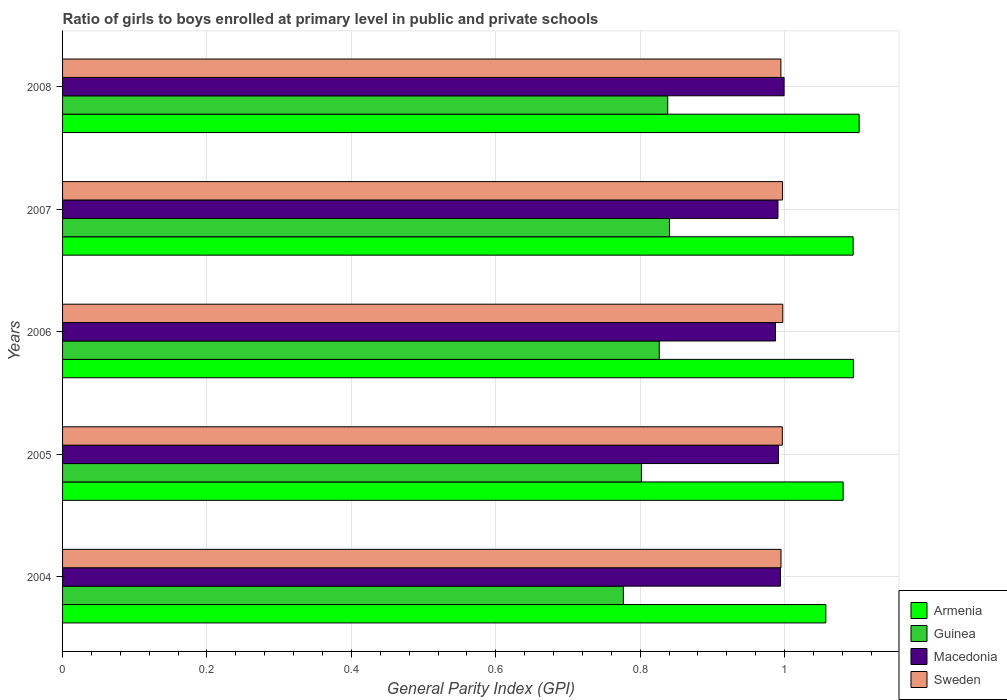How many groups of bars are there?
Your answer should be very brief. 5. Are the number of bars per tick equal to the number of legend labels?
Provide a short and direct response. Yes. How many bars are there on the 5th tick from the top?
Provide a succinct answer. 4. How many bars are there on the 1st tick from the bottom?
Offer a terse response. 4. What is the label of the 5th group of bars from the top?
Your response must be concise. 2004. In how many cases, is the number of bars for a given year not equal to the number of legend labels?
Ensure brevity in your answer.  0. What is the general parity index in Sweden in 2004?
Make the answer very short. 1. Across all years, what is the maximum general parity index in Macedonia?
Provide a short and direct response. 1. Across all years, what is the minimum general parity index in Sweden?
Give a very brief answer. 0.99. In which year was the general parity index in Sweden maximum?
Your response must be concise. 2006. What is the total general parity index in Sweden in the graph?
Give a very brief answer. 4.98. What is the difference between the general parity index in Sweden in 2004 and that in 2007?
Provide a succinct answer. -0. What is the difference between the general parity index in Guinea in 2006 and the general parity index in Macedonia in 2007?
Keep it short and to the point. -0.16. What is the average general parity index in Macedonia per year?
Your answer should be very brief. 0.99. In the year 2007, what is the difference between the general parity index in Sweden and general parity index in Armenia?
Your answer should be very brief. -0.1. In how many years, is the general parity index in Macedonia greater than 1.08 ?
Your answer should be very brief. 0. What is the ratio of the general parity index in Guinea in 2005 to that in 2008?
Your answer should be very brief. 0.96. What is the difference between the highest and the second highest general parity index in Sweden?
Ensure brevity in your answer.  0. What is the difference between the highest and the lowest general parity index in Macedonia?
Your answer should be very brief. 0.01. In how many years, is the general parity index in Armenia greater than the average general parity index in Armenia taken over all years?
Ensure brevity in your answer.  3. What does the 4th bar from the bottom in 2004 represents?
Make the answer very short. Sweden. What is the difference between two consecutive major ticks on the X-axis?
Keep it short and to the point. 0.2. Are the values on the major ticks of X-axis written in scientific E-notation?
Your response must be concise. No. Does the graph contain grids?
Keep it short and to the point. Yes. Where does the legend appear in the graph?
Ensure brevity in your answer.  Bottom right. How many legend labels are there?
Give a very brief answer. 4. What is the title of the graph?
Give a very brief answer. Ratio of girls to boys enrolled at primary level in public and private schools. What is the label or title of the X-axis?
Provide a succinct answer. General Parity Index (GPI). What is the label or title of the Y-axis?
Give a very brief answer. Years. What is the General Parity Index (GPI) in Armenia in 2004?
Ensure brevity in your answer.  1.06. What is the General Parity Index (GPI) of Guinea in 2004?
Ensure brevity in your answer.  0.78. What is the General Parity Index (GPI) of Macedonia in 2004?
Make the answer very short. 0.99. What is the General Parity Index (GPI) of Sweden in 2004?
Keep it short and to the point. 1. What is the General Parity Index (GPI) of Armenia in 2005?
Your response must be concise. 1.08. What is the General Parity Index (GPI) in Guinea in 2005?
Give a very brief answer. 0.8. What is the General Parity Index (GPI) of Macedonia in 2005?
Ensure brevity in your answer.  0.99. What is the General Parity Index (GPI) of Sweden in 2005?
Offer a terse response. 1. What is the General Parity Index (GPI) in Armenia in 2006?
Give a very brief answer. 1.1. What is the General Parity Index (GPI) of Guinea in 2006?
Provide a succinct answer. 0.83. What is the General Parity Index (GPI) in Macedonia in 2006?
Your answer should be compact. 0.99. What is the General Parity Index (GPI) in Sweden in 2006?
Your answer should be compact. 1. What is the General Parity Index (GPI) in Armenia in 2007?
Give a very brief answer. 1.1. What is the General Parity Index (GPI) of Guinea in 2007?
Offer a terse response. 0.84. What is the General Parity Index (GPI) in Macedonia in 2007?
Offer a terse response. 0.99. What is the General Parity Index (GPI) in Sweden in 2007?
Provide a short and direct response. 1. What is the General Parity Index (GPI) of Armenia in 2008?
Keep it short and to the point. 1.1. What is the General Parity Index (GPI) of Guinea in 2008?
Make the answer very short. 0.84. What is the General Parity Index (GPI) of Macedonia in 2008?
Ensure brevity in your answer.  1. What is the General Parity Index (GPI) in Sweden in 2008?
Give a very brief answer. 0.99. Across all years, what is the maximum General Parity Index (GPI) of Armenia?
Provide a short and direct response. 1.1. Across all years, what is the maximum General Parity Index (GPI) in Guinea?
Offer a very short reply. 0.84. Across all years, what is the maximum General Parity Index (GPI) of Macedonia?
Provide a succinct answer. 1. Across all years, what is the maximum General Parity Index (GPI) of Sweden?
Offer a terse response. 1. Across all years, what is the minimum General Parity Index (GPI) of Armenia?
Make the answer very short. 1.06. Across all years, what is the minimum General Parity Index (GPI) of Guinea?
Offer a very short reply. 0.78. Across all years, what is the minimum General Parity Index (GPI) in Macedonia?
Your answer should be very brief. 0.99. Across all years, what is the minimum General Parity Index (GPI) of Sweden?
Keep it short and to the point. 0.99. What is the total General Parity Index (GPI) of Armenia in the graph?
Provide a succinct answer. 5.43. What is the total General Parity Index (GPI) of Guinea in the graph?
Give a very brief answer. 4.08. What is the total General Parity Index (GPI) in Macedonia in the graph?
Provide a short and direct response. 4.96. What is the total General Parity Index (GPI) of Sweden in the graph?
Your answer should be compact. 4.98. What is the difference between the General Parity Index (GPI) of Armenia in 2004 and that in 2005?
Ensure brevity in your answer.  -0.02. What is the difference between the General Parity Index (GPI) in Guinea in 2004 and that in 2005?
Ensure brevity in your answer.  -0.03. What is the difference between the General Parity Index (GPI) of Macedonia in 2004 and that in 2005?
Keep it short and to the point. 0. What is the difference between the General Parity Index (GPI) in Sweden in 2004 and that in 2005?
Provide a succinct answer. -0. What is the difference between the General Parity Index (GPI) in Armenia in 2004 and that in 2006?
Provide a succinct answer. -0.04. What is the difference between the General Parity Index (GPI) of Guinea in 2004 and that in 2006?
Your answer should be compact. -0.05. What is the difference between the General Parity Index (GPI) of Macedonia in 2004 and that in 2006?
Make the answer very short. 0.01. What is the difference between the General Parity Index (GPI) of Sweden in 2004 and that in 2006?
Offer a very short reply. -0. What is the difference between the General Parity Index (GPI) of Armenia in 2004 and that in 2007?
Your answer should be compact. -0.04. What is the difference between the General Parity Index (GPI) in Guinea in 2004 and that in 2007?
Ensure brevity in your answer.  -0.06. What is the difference between the General Parity Index (GPI) of Macedonia in 2004 and that in 2007?
Offer a terse response. 0. What is the difference between the General Parity Index (GPI) of Sweden in 2004 and that in 2007?
Keep it short and to the point. -0. What is the difference between the General Parity Index (GPI) of Armenia in 2004 and that in 2008?
Offer a terse response. -0.05. What is the difference between the General Parity Index (GPI) of Guinea in 2004 and that in 2008?
Keep it short and to the point. -0.06. What is the difference between the General Parity Index (GPI) of Macedonia in 2004 and that in 2008?
Give a very brief answer. -0.01. What is the difference between the General Parity Index (GPI) of Sweden in 2004 and that in 2008?
Your answer should be very brief. 0. What is the difference between the General Parity Index (GPI) of Armenia in 2005 and that in 2006?
Make the answer very short. -0.01. What is the difference between the General Parity Index (GPI) in Guinea in 2005 and that in 2006?
Ensure brevity in your answer.  -0.02. What is the difference between the General Parity Index (GPI) of Macedonia in 2005 and that in 2006?
Ensure brevity in your answer.  0. What is the difference between the General Parity Index (GPI) in Sweden in 2005 and that in 2006?
Provide a succinct answer. -0. What is the difference between the General Parity Index (GPI) of Armenia in 2005 and that in 2007?
Provide a succinct answer. -0.01. What is the difference between the General Parity Index (GPI) in Guinea in 2005 and that in 2007?
Your answer should be very brief. -0.04. What is the difference between the General Parity Index (GPI) of Macedonia in 2005 and that in 2007?
Your answer should be very brief. 0. What is the difference between the General Parity Index (GPI) in Sweden in 2005 and that in 2007?
Your response must be concise. -0. What is the difference between the General Parity Index (GPI) in Armenia in 2005 and that in 2008?
Keep it short and to the point. -0.02. What is the difference between the General Parity Index (GPI) of Guinea in 2005 and that in 2008?
Offer a very short reply. -0.04. What is the difference between the General Parity Index (GPI) of Macedonia in 2005 and that in 2008?
Provide a succinct answer. -0.01. What is the difference between the General Parity Index (GPI) of Sweden in 2005 and that in 2008?
Your answer should be compact. 0. What is the difference between the General Parity Index (GPI) in Armenia in 2006 and that in 2007?
Make the answer very short. 0. What is the difference between the General Parity Index (GPI) in Guinea in 2006 and that in 2007?
Offer a terse response. -0.01. What is the difference between the General Parity Index (GPI) of Macedonia in 2006 and that in 2007?
Keep it short and to the point. -0. What is the difference between the General Parity Index (GPI) of Armenia in 2006 and that in 2008?
Make the answer very short. -0.01. What is the difference between the General Parity Index (GPI) in Guinea in 2006 and that in 2008?
Ensure brevity in your answer.  -0.01. What is the difference between the General Parity Index (GPI) in Macedonia in 2006 and that in 2008?
Your answer should be very brief. -0.01. What is the difference between the General Parity Index (GPI) in Sweden in 2006 and that in 2008?
Your answer should be very brief. 0. What is the difference between the General Parity Index (GPI) in Armenia in 2007 and that in 2008?
Make the answer very short. -0.01. What is the difference between the General Parity Index (GPI) in Guinea in 2007 and that in 2008?
Offer a terse response. 0. What is the difference between the General Parity Index (GPI) of Macedonia in 2007 and that in 2008?
Offer a terse response. -0.01. What is the difference between the General Parity Index (GPI) of Sweden in 2007 and that in 2008?
Offer a very short reply. 0. What is the difference between the General Parity Index (GPI) of Armenia in 2004 and the General Parity Index (GPI) of Guinea in 2005?
Offer a terse response. 0.26. What is the difference between the General Parity Index (GPI) of Armenia in 2004 and the General Parity Index (GPI) of Macedonia in 2005?
Provide a short and direct response. 0.07. What is the difference between the General Parity Index (GPI) of Armenia in 2004 and the General Parity Index (GPI) of Sweden in 2005?
Provide a short and direct response. 0.06. What is the difference between the General Parity Index (GPI) in Guinea in 2004 and the General Parity Index (GPI) in Macedonia in 2005?
Provide a short and direct response. -0.21. What is the difference between the General Parity Index (GPI) in Guinea in 2004 and the General Parity Index (GPI) in Sweden in 2005?
Provide a short and direct response. -0.22. What is the difference between the General Parity Index (GPI) of Macedonia in 2004 and the General Parity Index (GPI) of Sweden in 2005?
Your answer should be compact. -0. What is the difference between the General Parity Index (GPI) of Armenia in 2004 and the General Parity Index (GPI) of Guinea in 2006?
Ensure brevity in your answer.  0.23. What is the difference between the General Parity Index (GPI) in Armenia in 2004 and the General Parity Index (GPI) in Macedonia in 2006?
Your response must be concise. 0.07. What is the difference between the General Parity Index (GPI) of Armenia in 2004 and the General Parity Index (GPI) of Sweden in 2006?
Your answer should be very brief. 0.06. What is the difference between the General Parity Index (GPI) of Guinea in 2004 and the General Parity Index (GPI) of Macedonia in 2006?
Provide a succinct answer. -0.21. What is the difference between the General Parity Index (GPI) in Guinea in 2004 and the General Parity Index (GPI) in Sweden in 2006?
Provide a succinct answer. -0.22. What is the difference between the General Parity Index (GPI) in Macedonia in 2004 and the General Parity Index (GPI) in Sweden in 2006?
Keep it short and to the point. -0. What is the difference between the General Parity Index (GPI) in Armenia in 2004 and the General Parity Index (GPI) in Guinea in 2007?
Keep it short and to the point. 0.22. What is the difference between the General Parity Index (GPI) in Armenia in 2004 and the General Parity Index (GPI) in Macedonia in 2007?
Make the answer very short. 0.07. What is the difference between the General Parity Index (GPI) of Armenia in 2004 and the General Parity Index (GPI) of Sweden in 2007?
Offer a very short reply. 0.06. What is the difference between the General Parity Index (GPI) of Guinea in 2004 and the General Parity Index (GPI) of Macedonia in 2007?
Your answer should be very brief. -0.21. What is the difference between the General Parity Index (GPI) in Guinea in 2004 and the General Parity Index (GPI) in Sweden in 2007?
Your response must be concise. -0.22. What is the difference between the General Parity Index (GPI) of Macedonia in 2004 and the General Parity Index (GPI) of Sweden in 2007?
Your response must be concise. -0. What is the difference between the General Parity Index (GPI) of Armenia in 2004 and the General Parity Index (GPI) of Guinea in 2008?
Make the answer very short. 0.22. What is the difference between the General Parity Index (GPI) in Armenia in 2004 and the General Parity Index (GPI) in Macedonia in 2008?
Provide a short and direct response. 0.06. What is the difference between the General Parity Index (GPI) of Armenia in 2004 and the General Parity Index (GPI) of Sweden in 2008?
Ensure brevity in your answer.  0.06. What is the difference between the General Parity Index (GPI) in Guinea in 2004 and the General Parity Index (GPI) in Macedonia in 2008?
Offer a very short reply. -0.22. What is the difference between the General Parity Index (GPI) of Guinea in 2004 and the General Parity Index (GPI) of Sweden in 2008?
Offer a very short reply. -0.22. What is the difference between the General Parity Index (GPI) in Macedonia in 2004 and the General Parity Index (GPI) in Sweden in 2008?
Ensure brevity in your answer.  -0. What is the difference between the General Parity Index (GPI) of Armenia in 2005 and the General Parity Index (GPI) of Guinea in 2006?
Offer a very short reply. 0.25. What is the difference between the General Parity Index (GPI) of Armenia in 2005 and the General Parity Index (GPI) of Macedonia in 2006?
Provide a succinct answer. 0.09. What is the difference between the General Parity Index (GPI) in Armenia in 2005 and the General Parity Index (GPI) in Sweden in 2006?
Your answer should be compact. 0.08. What is the difference between the General Parity Index (GPI) in Guinea in 2005 and the General Parity Index (GPI) in Macedonia in 2006?
Keep it short and to the point. -0.19. What is the difference between the General Parity Index (GPI) of Guinea in 2005 and the General Parity Index (GPI) of Sweden in 2006?
Your answer should be very brief. -0.2. What is the difference between the General Parity Index (GPI) in Macedonia in 2005 and the General Parity Index (GPI) in Sweden in 2006?
Make the answer very short. -0.01. What is the difference between the General Parity Index (GPI) in Armenia in 2005 and the General Parity Index (GPI) in Guinea in 2007?
Make the answer very short. 0.24. What is the difference between the General Parity Index (GPI) in Armenia in 2005 and the General Parity Index (GPI) in Macedonia in 2007?
Give a very brief answer. 0.09. What is the difference between the General Parity Index (GPI) in Armenia in 2005 and the General Parity Index (GPI) in Sweden in 2007?
Your answer should be compact. 0.08. What is the difference between the General Parity Index (GPI) in Guinea in 2005 and the General Parity Index (GPI) in Macedonia in 2007?
Provide a succinct answer. -0.19. What is the difference between the General Parity Index (GPI) of Guinea in 2005 and the General Parity Index (GPI) of Sweden in 2007?
Ensure brevity in your answer.  -0.2. What is the difference between the General Parity Index (GPI) in Macedonia in 2005 and the General Parity Index (GPI) in Sweden in 2007?
Offer a terse response. -0.01. What is the difference between the General Parity Index (GPI) in Armenia in 2005 and the General Parity Index (GPI) in Guinea in 2008?
Your answer should be very brief. 0.24. What is the difference between the General Parity Index (GPI) in Armenia in 2005 and the General Parity Index (GPI) in Macedonia in 2008?
Your answer should be compact. 0.08. What is the difference between the General Parity Index (GPI) of Armenia in 2005 and the General Parity Index (GPI) of Sweden in 2008?
Offer a terse response. 0.09. What is the difference between the General Parity Index (GPI) in Guinea in 2005 and the General Parity Index (GPI) in Macedonia in 2008?
Offer a very short reply. -0.2. What is the difference between the General Parity Index (GPI) in Guinea in 2005 and the General Parity Index (GPI) in Sweden in 2008?
Offer a very short reply. -0.19. What is the difference between the General Parity Index (GPI) in Macedonia in 2005 and the General Parity Index (GPI) in Sweden in 2008?
Make the answer very short. -0. What is the difference between the General Parity Index (GPI) of Armenia in 2006 and the General Parity Index (GPI) of Guinea in 2007?
Your answer should be very brief. 0.25. What is the difference between the General Parity Index (GPI) of Armenia in 2006 and the General Parity Index (GPI) of Macedonia in 2007?
Your answer should be very brief. 0.1. What is the difference between the General Parity Index (GPI) in Armenia in 2006 and the General Parity Index (GPI) in Sweden in 2007?
Provide a succinct answer. 0.1. What is the difference between the General Parity Index (GPI) in Guinea in 2006 and the General Parity Index (GPI) in Macedonia in 2007?
Ensure brevity in your answer.  -0.16. What is the difference between the General Parity Index (GPI) in Guinea in 2006 and the General Parity Index (GPI) in Sweden in 2007?
Provide a succinct answer. -0.17. What is the difference between the General Parity Index (GPI) in Macedonia in 2006 and the General Parity Index (GPI) in Sweden in 2007?
Offer a terse response. -0.01. What is the difference between the General Parity Index (GPI) of Armenia in 2006 and the General Parity Index (GPI) of Guinea in 2008?
Give a very brief answer. 0.26. What is the difference between the General Parity Index (GPI) in Armenia in 2006 and the General Parity Index (GPI) in Macedonia in 2008?
Provide a short and direct response. 0.1. What is the difference between the General Parity Index (GPI) of Armenia in 2006 and the General Parity Index (GPI) of Sweden in 2008?
Offer a very short reply. 0.1. What is the difference between the General Parity Index (GPI) of Guinea in 2006 and the General Parity Index (GPI) of Macedonia in 2008?
Offer a terse response. -0.17. What is the difference between the General Parity Index (GPI) in Guinea in 2006 and the General Parity Index (GPI) in Sweden in 2008?
Your response must be concise. -0.17. What is the difference between the General Parity Index (GPI) in Macedonia in 2006 and the General Parity Index (GPI) in Sweden in 2008?
Offer a terse response. -0.01. What is the difference between the General Parity Index (GPI) in Armenia in 2007 and the General Parity Index (GPI) in Guinea in 2008?
Give a very brief answer. 0.26. What is the difference between the General Parity Index (GPI) in Armenia in 2007 and the General Parity Index (GPI) in Macedonia in 2008?
Your answer should be very brief. 0.1. What is the difference between the General Parity Index (GPI) in Armenia in 2007 and the General Parity Index (GPI) in Sweden in 2008?
Your answer should be compact. 0.1. What is the difference between the General Parity Index (GPI) of Guinea in 2007 and the General Parity Index (GPI) of Macedonia in 2008?
Make the answer very short. -0.16. What is the difference between the General Parity Index (GPI) in Guinea in 2007 and the General Parity Index (GPI) in Sweden in 2008?
Offer a very short reply. -0.15. What is the difference between the General Parity Index (GPI) of Macedonia in 2007 and the General Parity Index (GPI) of Sweden in 2008?
Offer a terse response. -0. What is the average General Parity Index (GPI) of Armenia per year?
Provide a succinct answer. 1.09. What is the average General Parity Index (GPI) in Guinea per year?
Provide a succinct answer. 0.82. What is the average General Parity Index (GPI) in Macedonia per year?
Keep it short and to the point. 0.99. What is the average General Parity Index (GPI) of Sweden per year?
Offer a terse response. 1. In the year 2004, what is the difference between the General Parity Index (GPI) in Armenia and General Parity Index (GPI) in Guinea?
Your response must be concise. 0.28. In the year 2004, what is the difference between the General Parity Index (GPI) in Armenia and General Parity Index (GPI) in Macedonia?
Ensure brevity in your answer.  0.06. In the year 2004, what is the difference between the General Parity Index (GPI) of Armenia and General Parity Index (GPI) of Sweden?
Make the answer very short. 0.06. In the year 2004, what is the difference between the General Parity Index (GPI) in Guinea and General Parity Index (GPI) in Macedonia?
Ensure brevity in your answer.  -0.22. In the year 2004, what is the difference between the General Parity Index (GPI) of Guinea and General Parity Index (GPI) of Sweden?
Provide a short and direct response. -0.22. In the year 2004, what is the difference between the General Parity Index (GPI) of Macedonia and General Parity Index (GPI) of Sweden?
Your answer should be compact. -0. In the year 2005, what is the difference between the General Parity Index (GPI) in Armenia and General Parity Index (GPI) in Guinea?
Your answer should be very brief. 0.28. In the year 2005, what is the difference between the General Parity Index (GPI) in Armenia and General Parity Index (GPI) in Macedonia?
Provide a succinct answer. 0.09. In the year 2005, what is the difference between the General Parity Index (GPI) of Armenia and General Parity Index (GPI) of Sweden?
Make the answer very short. 0.08. In the year 2005, what is the difference between the General Parity Index (GPI) in Guinea and General Parity Index (GPI) in Macedonia?
Ensure brevity in your answer.  -0.19. In the year 2005, what is the difference between the General Parity Index (GPI) in Guinea and General Parity Index (GPI) in Sweden?
Your answer should be compact. -0.2. In the year 2005, what is the difference between the General Parity Index (GPI) of Macedonia and General Parity Index (GPI) of Sweden?
Keep it short and to the point. -0.01. In the year 2006, what is the difference between the General Parity Index (GPI) of Armenia and General Parity Index (GPI) of Guinea?
Make the answer very short. 0.27. In the year 2006, what is the difference between the General Parity Index (GPI) of Armenia and General Parity Index (GPI) of Macedonia?
Offer a terse response. 0.11. In the year 2006, what is the difference between the General Parity Index (GPI) of Armenia and General Parity Index (GPI) of Sweden?
Make the answer very short. 0.1. In the year 2006, what is the difference between the General Parity Index (GPI) in Guinea and General Parity Index (GPI) in Macedonia?
Your answer should be very brief. -0.16. In the year 2006, what is the difference between the General Parity Index (GPI) in Guinea and General Parity Index (GPI) in Sweden?
Provide a succinct answer. -0.17. In the year 2006, what is the difference between the General Parity Index (GPI) in Macedonia and General Parity Index (GPI) in Sweden?
Offer a very short reply. -0.01. In the year 2007, what is the difference between the General Parity Index (GPI) of Armenia and General Parity Index (GPI) of Guinea?
Keep it short and to the point. 0.25. In the year 2007, what is the difference between the General Parity Index (GPI) in Armenia and General Parity Index (GPI) in Macedonia?
Offer a terse response. 0.1. In the year 2007, what is the difference between the General Parity Index (GPI) of Armenia and General Parity Index (GPI) of Sweden?
Give a very brief answer. 0.1. In the year 2007, what is the difference between the General Parity Index (GPI) of Guinea and General Parity Index (GPI) of Macedonia?
Provide a short and direct response. -0.15. In the year 2007, what is the difference between the General Parity Index (GPI) of Guinea and General Parity Index (GPI) of Sweden?
Your response must be concise. -0.16. In the year 2007, what is the difference between the General Parity Index (GPI) in Macedonia and General Parity Index (GPI) in Sweden?
Keep it short and to the point. -0.01. In the year 2008, what is the difference between the General Parity Index (GPI) in Armenia and General Parity Index (GPI) in Guinea?
Keep it short and to the point. 0.27. In the year 2008, what is the difference between the General Parity Index (GPI) in Armenia and General Parity Index (GPI) in Macedonia?
Your answer should be very brief. 0.1. In the year 2008, what is the difference between the General Parity Index (GPI) of Armenia and General Parity Index (GPI) of Sweden?
Your answer should be very brief. 0.11. In the year 2008, what is the difference between the General Parity Index (GPI) in Guinea and General Parity Index (GPI) in Macedonia?
Provide a short and direct response. -0.16. In the year 2008, what is the difference between the General Parity Index (GPI) in Guinea and General Parity Index (GPI) in Sweden?
Give a very brief answer. -0.16. In the year 2008, what is the difference between the General Parity Index (GPI) of Macedonia and General Parity Index (GPI) of Sweden?
Provide a short and direct response. 0. What is the ratio of the General Parity Index (GPI) of Armenia in 2004 to that in 2005?
Offer a very short reply. 0.98. What is the ratio of the General Parity Index (GPI) of Guinea in 2004 to that in 2005?
Your response must be concise. 0.97. What is the ratio of the General Parity Index (GPI) of Armenia in 2004 to that in 2006?
Ensure brevity in your answer.  0.97. What is the ratio of the General Parity Index (GPI) in Guinea in 2004 to that in 2006?
Ensure brevity in your answer.  0.94. What is the ratio of the General Parity Index (GPI) in Armenia in 2004 to that in 2007?
Your answer should be very brief. 0.97. What is the ratio of the General Parity Index (GPI) of Guinea in 2004 to that in 2007?
Your answer should be very brief. 0.92. What is the ratio of the General Parity Index (GPI) of Sweden in 2004 to that in 2007?
Keep it short and to the point. 1. What is the ratio of the General Parity Index (GPI) in Armenia in 2004 to that in 2008?
Keep it short and to the point. 0.96. What is the ratio of the General Parity Index (GPI) of Guinea in 2004 to that in 2008?
Offer a terse response. 0.93. What is the ratio of the General Parity Index (GPI) of Macedonia in 2004 to that in 2008?
Your answer should be very brief. 0.99. What is the ratio of the General Parity Index (GPI) of Armenia in 2005 to that in 2006?
Keep it short and to the point. 0.99. What is the ratio of the General Parity Index (GPI) of Guinea in 2005 to that in 2006?
Your response must be concise. 0.97. What is the ratio of the General Parity Index (GPI) in Macedonia in 2005 to that in 2006?
Ensure brevity in your answer.  1. What is the ratio of the General Parity Index (GPI) of Armenia in 2005 to that in 2007?
Provide a succinct answer. 0.99. What is the ratio of the General Parity Index (GPI) in Guinea in 2005 to that in 2007?
Your response must be concise. 0.95. What is the ratio of the General Parity Index (GPI) of Armenia in 2005 to that in 2008?
Offer a very short reply. 0.98. What is the ratio of the General Parity Index (GPI) in Guinea in 2005 to that in 2008?
Keep it short and to the point. 0.96. What is the ratio of the General Parity Index (GPI) of Sweden in 2005 to that in 2008?
Your response must be concise. 1. What is the ratio of the General Parity Index (GPI) of Guinea in 2006 to that in 2007?
Your answer should be compact. 0.98. What is the ratio of the General Parity Index (GPI) in Armenia in 2006 to that in 2008?
Your answer should be compact. 0.99. What is the ratio of the General Parity Index (GPI) in Guinea in 2006 to that in 2008?
Provide a short and direct response. 0.99. What is the ratio of the General Parity Index (GPI) in Macedonia in 2006 to that in 2008?
Your response must be concise. 0.99. What is the ratio of the General Parity Index (GPI) of Sweden in 2006 to that in 2008?
Offer a very short reply. 1. What is the ratio of the General Parity Index (GPI) of Armenia in 2007 to that in 2008?
Your response must be concise. 0.99. What is the ratio of the General Parity Index (GPI) of Guinea in 2007 to that in 2008?
Your response must be concise. 1. What is the difference between the highest and the second highest General Parity Index (GPI) in Armenia?
Ensure brevity in your answer.  0.01. What is the difference between the highest and the second highest General Parity Index (GPI) in Guinea?
Ensure brevity in your answer.  0. What is the difference between the highest and the second highest General Parity Index (GPI) in Macedonia?
Your answer should be compact. 0.01. What is the difference between the highest and the lowest General Parity Index (GPI) in Armenia?
Your answer should be compact. 0.05. What is the difference between the highest and the lowest General Parity Index (GPI) of Guinea?
Provide a succinct answer. 0.06. What is the difference between the highest and the lowest General Parity Index (GPI) in Macedonia?
Offer a very short reply. 0.01. What is the difference between the highest and the lowest General Parity Index (GPI) of Sweden?
Your answer should be compact. 0. 